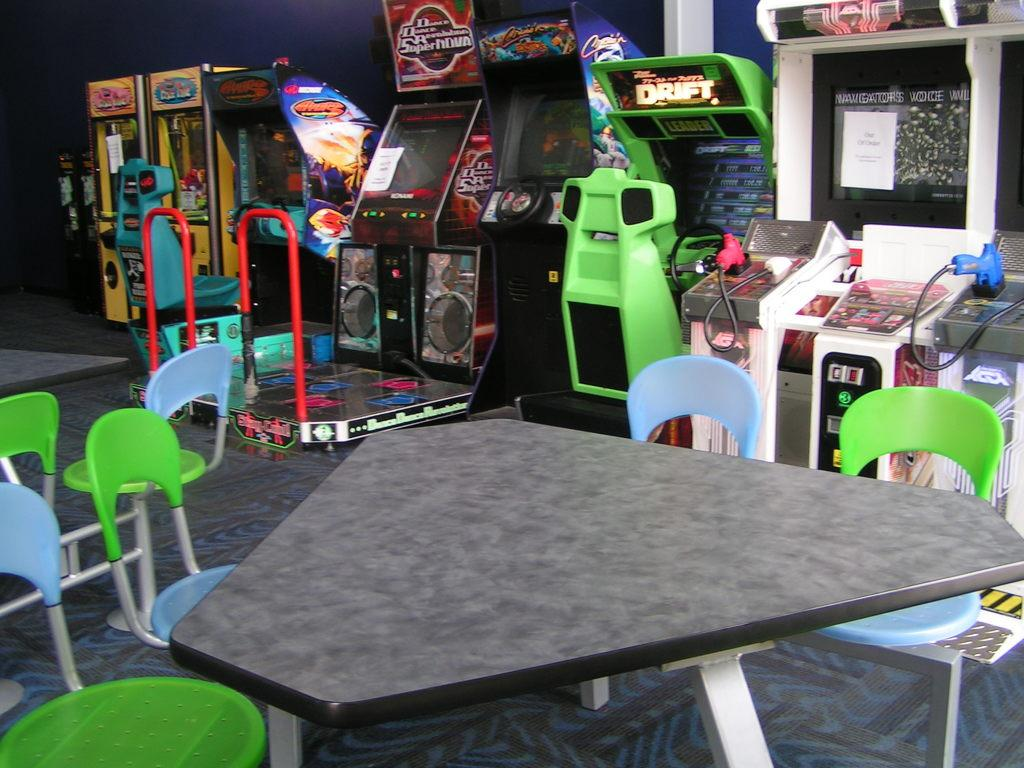What is located at the bottom of the image? There is a table at the bottom of the image. What furniture is present in the image? There are chairs in the image. What can be seen in the background of the image? There is a game zone and a wall in the background of the image. How many sacks are being used as part of the game in the image? There is no mention of sacks or a game involving sacks in the image. What type of meal is being prepared on the table in the image? There is no indication of a meal being prepared on the table in the image. 